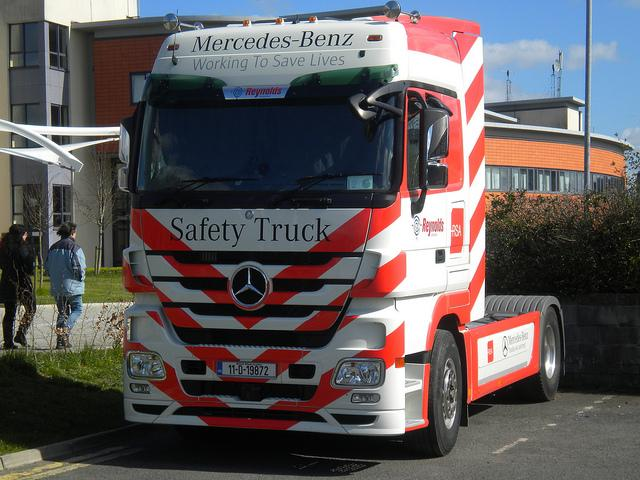What is the most appropriate surface for this truck to drive on?

Choices:
A) grass
B) asphalt
C) sidewalk
D) concrete asphalt 